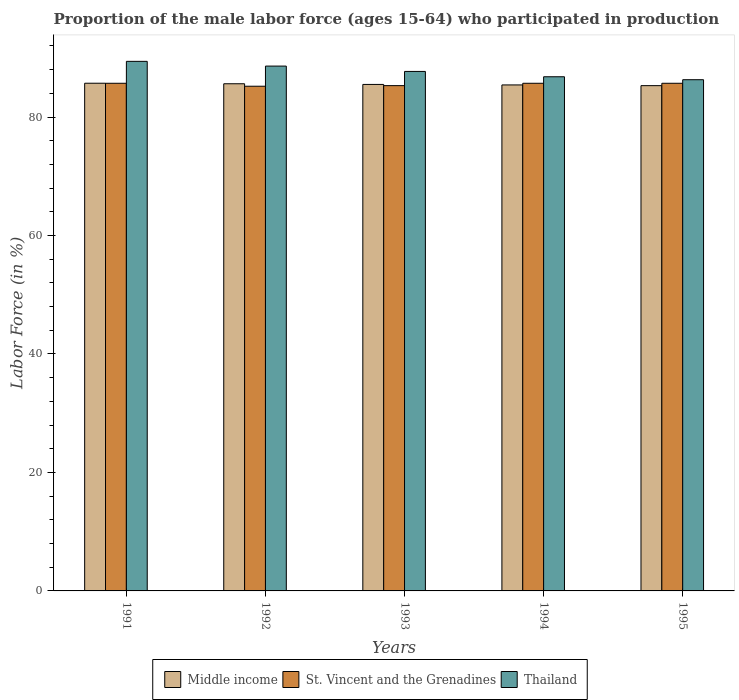How many different coloured bars are there?
Your answer should be compact. 3. How many groups of bars are there?
Make the answer very short. 5. Are the number of bars on each tick of the X-axis equal?
Provide a succinct answer. Yes. How many bars are there on the 4th tick from the left?
Give a very brief answer. 3. In how many cases, is the number of bars for a given year not equal to the number of legend labels?
Your response must be concise. 0. What is the proportion of the male labor force who participated in production in Middle income in 1992?
Offer a very short reply. 85.62. Across all years, what is the maximum proportion of the male labor force who participated in production in Thailand?
Provide a short and direct response. 89.4. Across all years, what is the minimum proportion of the male labor force who participated in production in Middle income?
Provide a succinct answer. 85.3. What is the total proportion of the male labor force who participated in production in St. Vincent and the Grenadines in the graph?
Provide a short and direct response. 427.6. What is the difference between the proportion of the male labor force who participated in production in Thailand in 1992 and that in 1993?
Provide a short and direct response. 0.9. What is the difference between the proportion of the male labor force who participated in production in St. Vincent and the Grenadines in 1991 and the proportion of the male labor force who participated in production in Middle income in 1994?
Offer a very short reply. 0.28. What is the average proportion of the male labor force who participated in production in Thailand per year?
Offer a terse response. 87.76. In the year 1993, what is the difference between the proportion of the male labor force who participated in production in Middle income and proportion of the male labor force who participated in production in St. Vincent and the Grenadines?
Offer a very short reply. 0.2. In how many years, is the proportion of the male labor force who participated in production in Middle income greater than 84 %?
Provide a short and direct response. 5. What is the ratio of the proportion of the male labor force who participated in production in Thailand in 1993 to that in 1995?
Your answer should be compact. 1.02. Is the proportion of the male labor force who participated in production in Thailand in 1991 less than that in 1993?
Your response must be concise. No. What is the difference between the highest and the second highest proportion of the male labor force who participated in production in Middle income?
Ensure brevity in your answer.  0.09. What is the difference between the highest and the lowest proportion of the male labor force who participated in production in St. Vincent and the Grenadines?
Offer a very short reply. 0.5. In how many years, is the proportion of the male labor force who participated in production in Middle income greater than the average proportion of the male labor force who participated in production in Middle income taken over all years?
Your answer should be compact. 2. What does the 3rd bar from the left in 1994 represents?
Offer a very short reply. Thailand. What does the 1st bar from the right in 1994 represents?
Your answer should be very brief. Thailand. How many years are there in the graph?
Your response must be concise. 5. Are the values on the major ticks of Y-axis written in scientific E-notation?
Make the answer very short. No. Does the graph contain any zero values?
Provide a short and direct response. No. Where does the legend appear in the graph?
Your response must be concise. Bottom center. What is the title of the graph?
Offer a terse response. Proportion of the male labor force (ages 15-64) who participated in production. What is the label or title of the X-axis?
Make the answer very short. Years. What is the Labor Force (in %) in Middle income in 1991?
Your answer should be compact. 85.71. What is the Labor Force (in %) of St. Vincent and the Grenadines in 1991?
Your answer should be compact. 85.7. What is the Labor Force (in %) of Thailand in 1991?
Your answer should be compact. 89.4. What is the Labor Force (in %) in Middle income in 1992?
Offer a very short reply. 85.62. What is the Labor Force (in %) of St. Vincent and the Grenadines in 1992?
Offer a terse response. 85.2. What is the Labor Force (in %) in Thailand in 1992?
Make the answer very short. 88.6. What is the Labor Force (in %) of Middle income in 1993?
Provide a short and direct response. 85.5. What is the Labor Force (in %) of St. Vincent and the Grenadines in 1993?
Provide a short and direct response. 85.3. What is the Labor Force (in %) in Thailand in 1993?
Ensure brevity in your answer.  87.7. What is the Labor Force (in %) of Middle income in 1994?
Your response must be concise. 85.42. What is the Labor Force (in %) in St. Vincent and the Grenadines in 1994?
Ensure brevity in your answer.  85.7. What is the Labor Force (in %) in Thailand in 1994?
Your answer should be compact. 86.8. What is the Labor Force (in %) in Middle income in 1995?
Provide a succinct answer. 85.3. What is the Labor Force (in %) in St. Vincent and the Grenadines in 1995?
Provide a succinct answer. 85.7. What is the Labor Force (in %) in Thailand in 1995?
Keep it short and to the point. 86.3. Across all years, what is the maximum Labor Force (in %) of Middle income?
Give a very brief answer. 85.71. Across all years, what is the maximum Labor Force (in %) in St. Vincent and the Grenadines?
Keep it short and to the point. 85.7. Across all years, what is the maximum Labor Force (in %) of Thailand?
Provide a short and direct response. 89.4. Across all years, what is the minimum Labor Force (in %) in Middle income?
Offer a terse response. 85.3. Across all years, what is the minimum Labor Force (in %) in St. Vincent and the Grenadines?
Keep it short and to the point. 85.2. Across all years, what is the minimum Labor Force (in %) of Thailand?
Ensure brevity in your answer.  86.3. What is the total Labor Force (in %) in Middle income in the graph?
Provide a succinct answer. 427.55. What is the total Labor Force (in %) in St. Vincent and the Grenadines in the graph?
Offer a terse response. 427.6. What is the total Labor Force (in %) in Thailand in the graph?
Your answer should be compact. 438.8. What is the difference between the Labor Force (in %) in Middle income in 1991 and that in 1992?
Your answer should be very brief. 0.09. What is the difference between the Labor Force (in %) of Middle income in 1991 and that in 1993?
Provide a succinct answer. 0.2. What is the difference between the Labor Force (in %) of St. Vincent and the Grenadines in 1991 and that in 1993?
Ensure brevity in your answer.  0.4. What is the difference between the Labor Force (in %) in Middle income in 1991 and that in 1994?
Provide a short and direct response. 0.29. What is the difference between the Labor Force (in %) of St. Vincent and the Grenadines in 1991 and that in 1994?
Your answer should be very brief. 0. What is the difference between the Labor Force (in %) of Thailand in 1991 and that in 1994?
Make the answer very short. 2.6. What is the difference between the Labor Force (in %) of Middle income in 1991 and that in 1995?
Provide a succinct answer. 0.41. What is the difference between the Labor Force (in %) in Thailand in 1991 and that in 1995?
Offer a very short reply. 3.1. What is the difference between the Labor Force (in %) in Middle income in 1992 and that in 1993?
Make the answer very short. 0.11. What is the difference between the Labor Force (in %) in St. Vincent and the Grenadines in 1992 and that in 1993?
Keep it short and to the point. -0.1. What is the difference between the Labor Force (in %) in Middle income in 1992 and that in 1994?
Your answer should be very brief. 0.2. What is the difference between the Labor Force (in %) in St. Vincent and the Grenadines in 1992 and that in 1994?
Provide a short and direct response. -0.5. What is the difference between the Labor Force (in %) in Middle income in 1992 and that in 1995?
Offer a terse response. 0.32. What is the difference between the Labor Force (in %) of Middle income in 1993 and that in 1994?
Ensure brevity in your answer.  0.09. What is the difference between the Labor Force (in %) of Middle income in 1993 and that in 1995?
Your answer should be compact. 0.21. What is the difference between the Labor Force (in %) of St. Vincent and the Grenadines in 1993 and that in 1995?
Make the answer very short. -0.4. What is the difference between the Labor Force (in %) of Middle income in 1994 and that in 1995?
Provide a succinct answer. 0.12. What is the difference between the Labor Force (in %) in St. Vincent and the Grenadines in 1994 and that in 1995?
Your answer should be compact. 0. What is the difference between the Labor Force (in %) of Middle income in 1991 and the Labor Force (in %) of St. Vincent and the Grenadines in 1992?
Provide a short and direct response. 0.51. What is the difference between the Labor Force (in %) of Middle income in 1991 and the Labor Force (in %) of Thailand in 1992?
Keep it short and to the point. -2.89. What is the difference between the Labor Force (in %) of St. Vincent and the Grenadines in 1991 and the Labor Force (in %) of Thailand in 1992?
Make the answer very short. -2.9. What is the difference between the Labor Force (in %) of Middle income in 1991 and the Labor Force (in %) of St. Vincent and the Grenadines in 1993?
Provide a succinct answer. 0.41. What is the difference between the Labor Force (in %) of Middle income in 1991 and the Labor Force (in %) of Thailand in 1993?
Keep it short and to the point. -1.99. What is the difference between the Labor Force (in %) in St. Vincent and the Grenadines in 1991 and the Labor Force (in %) in Thailand in 1993?
Provide a succinct answer. -2. What is the difference between the Labor Force (in %) in Middle income in 1991 and the Labor Force (in %) in St. Vincent and the Grenadines in 1994?
Provide a succinct answer. 0.01. What is the difference between the Labor Force (in %) of Middle income in 1991 and the Labor Force (in %) of Thailand in 1994?
Provide a succinct answer. -1.09. What is the difference between the Labor Force (in %) of Middle income in 1991 and the Labor Force (in %) of St. Vincent and the Grenadines in 1995?
Make the answer very short. 0.01. What is the difference between the Labor Force (in %) in Middle income in 1991 and the Labor Force (in %) in Thailand in 1995?
Offer a very short reply. -0.59. What is the difference between the Labor Force (in %) of St. Vincent and the Grenadines in 1991 and the Labor Force (in %) of Thailand in 1995?
Offer a very short reply. -0.6. What is the difference between the Labor Force (in %) of Middle income in 1992 and the Labor Force (in %) of St. Vincent and the Grenadines in 1993?
Provide a succinct answer. 0.32. What is the difference between the Labor Force (in %) of Middle income in 1992 and the Labor Force (in %) of Thailand in 1993?
Your answer should be very brief. -2.08. What is the difference between the Labor Force (in %) of St. Vincent and the Grenadines in 1992 and the Labor Force (in %) of Thailand in 1993?
Your answer should be very brief. -2.5. What is the difference between the Labor Force (in %) of Middle income in 1992 and the Labor Force (in %) of St. Vincent and the Grenadines in 1994?
Your answer should be very brief. -0.08. What is the difference between the Labor Force (in %) of Middle income in 1992 and the Labor Force (in %) of Thailand in 1994?
Keep it short and to the point. -1.18. What is the difference between the Labor Force (in %) of Middle income in 1992 and the Labor Force (in %) of St. Vincent and the Grenadines in 1995?
Provide a short and direct response. -0.08. What is the difference between the Labor Force (in %) of Middle income in 1992 and the Labor Force (in %) of Thailand in 1995?
Offer a very short reply. -0.68. What is the difference between the Labor Force (in %) in Middle income in 1993 and the Labor Force (in %) in St. Vincent and the Grenadines in 1994?
Provide a succinct answer. -0.2. What is the difference between the Labor Force (in %) of Middle income in 1993 and the Labor Force (in %) of Thailand in 1994?
Make the answer very short. -1.3. What is the difference between the Labor Force (in %) in Middle income in 1993 and the Labor Force (in %) in St. Vincent and the Grenadines in 1995?
Offer a terse response. -0.2. What is the difference between the Labor Force (in %) in Middle income in 1993 and the Labor Force (in %) in Thailand in 1995?
Provide a succinct answer. -0.8. What is the difference between the Labor Force (in %) of Middle income in 1994 and the Labor Force (in %) of St. Vincent and the Grenadines in 1995?
Make the answer very short. -0.28. What is the difference between the Labor Force (in %) in Middle income in 1994 and the Labor Force (in %) in Thailand in 1995?
Your answer should be very brief. -0.88. What is the difference between the Labor Force (in %) of St. Vincent and the Grenadines in 1994 and the Labor Force (in %) of Thailand in 1995?
Keep it short and to the point. -0.6. What is the average Labor Force (in %) of Middle income per year?
Keep it short and to the point. 85.51. What is the average Labor Force (in %) of St. Vincent and the Grenadines per year?
Offer a very short reply. 85.52. What is the average Labor Force (in %) of Thailand per year?
Give a very brief answer. 87.76. In the year 1991, what is the difference between the Labor Force (in %) in Middle income and Labor Force (in %) in St. Vincent and the Grenadines?
Provide a succinct answer. 0.01. In the year 1991, what is the difference between the Labor Force (in %) of Middle income and Labor Force (in %) of Thailand?
Your answer should be compact. -3.69. In the year 1992, what is the difference between the Labor Force (in %) in Middle income and Labor Force (in %) in St. Vincent and the Grenadines?
Ensure brevity in your answer.  0.42. In the year 1992, what is the difference between the Labor Force (in %) of Middle income and Labor Force (in %) of Thailand?
Offer a terse response. -2.98. In the year 1993, what is the difference between the Labor Force (in %) in Middle income and Labor Force (in %) in St. Vincent and the Grenadines?
Your response must be concise. 0.2. In the year 1993, what is the difference between the Labor Force (in %) of Middle income and Labor Force (in %) of Thailand?
Offer a very short reply. -2.2. In the year 1993, what is the difference between the Labor Force (in %) in St. Vincent and the Grenadines and Labor Force (in %) in Thailand?
Ensure brevity in your answer.  -2.4. In the year 1994, what is the difference between the Labor Force (in %) in Middle income and Labor Force (in %) in St. Vincent and the Grenadines?
Your answer should be very brief. -0.28. In the year 1994, what is the difference between the Labor Force (in %) of Middle income and Labor Force (in %) of Thailand?
Provide a short and direct response. -1.38. In the year 1994, what is the difference between the Labor Force (in %) of St. Vincent and the Grenadines and Labor Force (in %) of Thailand?
Your answer should be very brief. -1.1. In the year 1995, what is the difference between the Labor Force (in %) in Middle income and Labor Force (in %) in St. Vincent and the Grenadines?
Your response must be concise. -0.4. In the year 1995, what is the difference between the Labor Force (in %) in Middle income and Labor Force (in %) in Thailand?
Ensure brevity in your answer.  -1. What is the ratio of the Labor Force (in %) of Middle income in 1991 to that in 1992?
Your response must be concise. 1. What is the ratio of the Labor Force (in %) in St. Vincent and the Grenadines in 1991 to that in 1992?
Provide a short and direct response. 1.01. What is the ratio of the Labor Force (in %) in Thailand in 1991 to that in 1992?
Give a very brief answer. 1.01. What is the ratio of the Labor Force (in %) in St. Vincent and the Grenadines in 1991 to that in 1993?
Offer a terse response. 1. What is the ratio of the Labor Force (in %) in Thailand in 1991 to that in 1993?
Your response must be concise. 1.02. What is the ratio of the Labor Force (in %) of Thailand in 1991 to that in 1994?
Offer a terse response. 1.03. What is the ratio of the Labor Force (in %) in Middle income in 1991 to that in 1995?
Offer a very short reply. 1. What is the ratio of the Labor Force (in %) of St. Vincent and the Grenadines in 1991 to that in 1995?
Your response must be concise. 1. What is the ratio of the Labor Force (in %) in Thailand in 1991 to that in 1995?
Your answer should be very brief. 1.04. What is the ratio of the Labor Force (in %) of Middle income in 1992 to that in 1993?
Your answer should be very brief. 1. What is the ratio of the Labor Force (in %) of Thailand in 1992 to that in 1993?
Your answer should be compact. 1.01. What is the ratio of the Labor Force (in %) in Thailand in 1992 to that in 1994?
Your answer should be compact. 1.02. What is the ratio of the Labor Force (in %) in St. Vincent and the Grenadines in 1992 to that in 1995?
Make the answer very short. 0.99. What is the ratio of the Labor Force (in %) of Thailand in 1992 to that in 1995?
Keep it short and to the point. 1.03. What is the ratio of the Labor Force (in %) in Middle income in 1993 to that in 1994?
Ensure brevity in your answer.  1. What is the ratio of the Labor Force (in %) in St. Vincent and the Grenadines in 1993 to that in 1994?
Keep it short and to the point. 1. What is the ratio of the Labor Force (in %) of Thailand in 1993 to that in 1994?
Offer a very short reply. 1.01. What is the ratio of the Labor Force (in %) of St. Vincent and the Grenadines in 1993 to that in 1995?
Your answer should be compact. 1. What is the ratio of the Labor Force (in %) of Thailand in 1993 to that in 1995?
Your answer should be very brief. 1.02. What is the ratio of the Labor Force (in %) of Middle income in 1994 to that in 1995?
Offer a very short reply. 1. What is the difference between the highest and the second highest Labor Force (in %) of Middle income?
Your answer should be compact. 0.09. What is the difference between the highest and the second highest Labor Force (in %) of St. Vincent and the Grenadines?
Keep it short and to the point. 0. What is the difference between the highest and the lowest Labor Force (in %) of Middle income?
Offer a terse response. 0.41. What is the difference between the highest and the lowest Labor Force (in %) in St. Vincent and the Grenadines?
Provide a short and direct response. 0.5. 